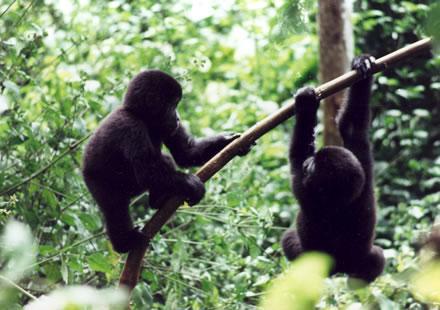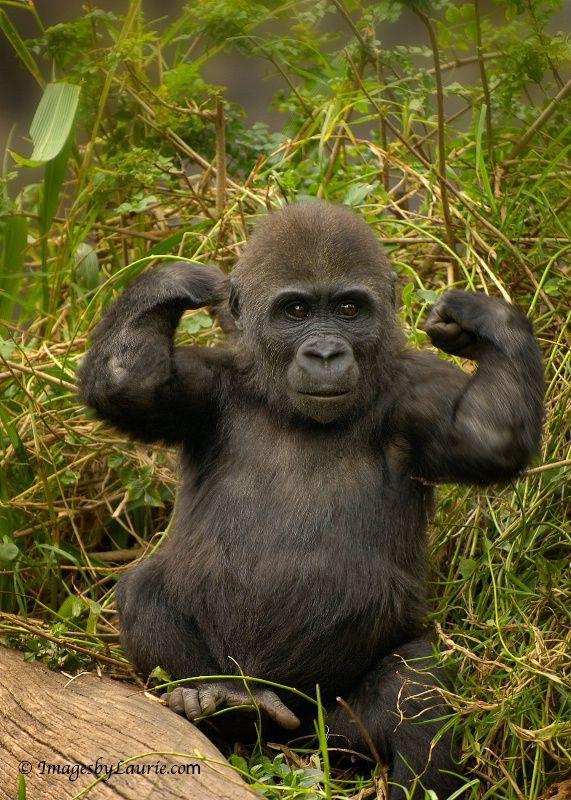The first image is the image on the left, the second image is the image on the right. Analyze the images presented: Is the assertion "One image shows two young gorillas playing on a tree branch, and one of them is climbing up the branch." valid? Answer yes or no. Yes. The first image is the image on the left, the second image is the image on the right. Analyze the images presented: Is the assertion "The left image contains no more than one gorilla." valid? Answer yes or no. No. 